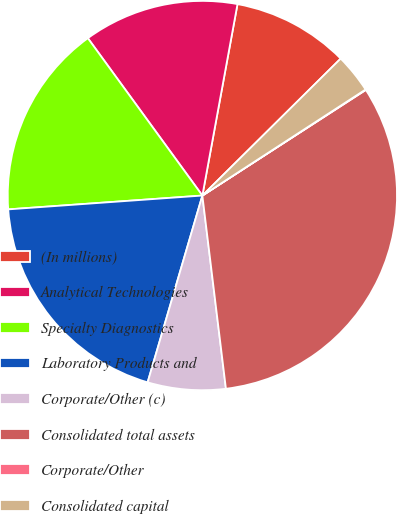Convert chart to OTSL. <chart><loc_0><loc_0><loc_500><loc_500><pie_chart><fcel>(In millions)<fcel>Analytical Technologies<fcel>Specialty Diagnostics<fcel>Laboratory Products and<fcel>Corporate/Other (c)<fcel>Consolidated total assets<fcel>Corporate/Other<fcel>Consolidated capital<nl><fcel>9.69%<fcel>12.9%<fcel>16.12%<fcel>19.33%<fcel>6.47%<fcel>32.2%<fcel>0.04%<fcel>3.25%<nl></chart> 